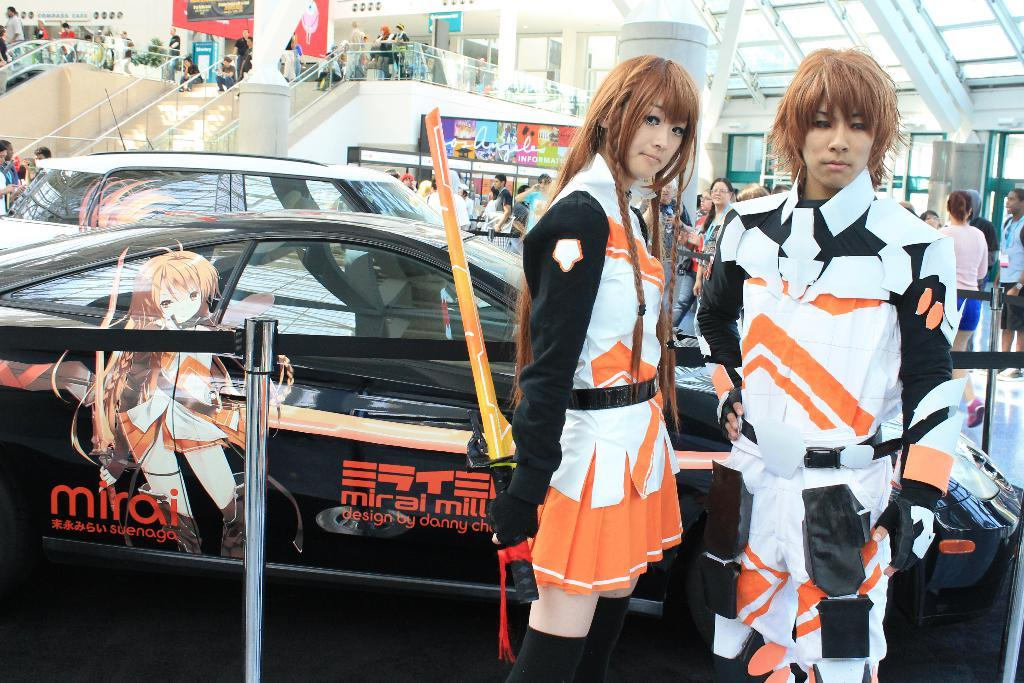What type of location is depicted in the image? The image appears to depict a mall. What are the people in the image doing? People are moving around the mall. Can you describe the scene involving the cars in the image? There are two people standing in front of cars. What kind of event might be taking place at the mall? It seems to be an expo or similar event. What type of garden can be seen in the image? There is no garden present in the image; it depicts a mall with people moving around and an expo-like event. What type of bread is being sold at the expo in the image? There is no mention of bread or any food items being sold in the image; it focuses on the mall and the people present. 